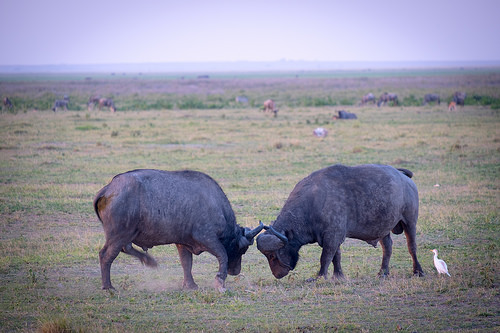<image>
Can you confirm if the cloud is behind the animal? Yes. From this viewpoint, the cloud is positioned behind the animal, with the animal partially or fully occluding the cloud. Where is the bird in relation to the bull? Is it in the bull? No. The bird is not contained within the bull. These objects have a different spatial relationship. 